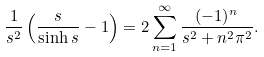Convert formula to latex. <formula><loc_0><loc_0><loc_500><loc_500>\frac { 1 } { s ^ { 2 } } \left ( \frac { s } { \sinh s } - 1 \right ) = 2 \sum _ { n = 1 } ^ { \infty } \frac { ( - 1 ) ^ { n } } { s ^ { 2 } + n ^ { 2 } \pi ^ { 2 } } .</formula> 